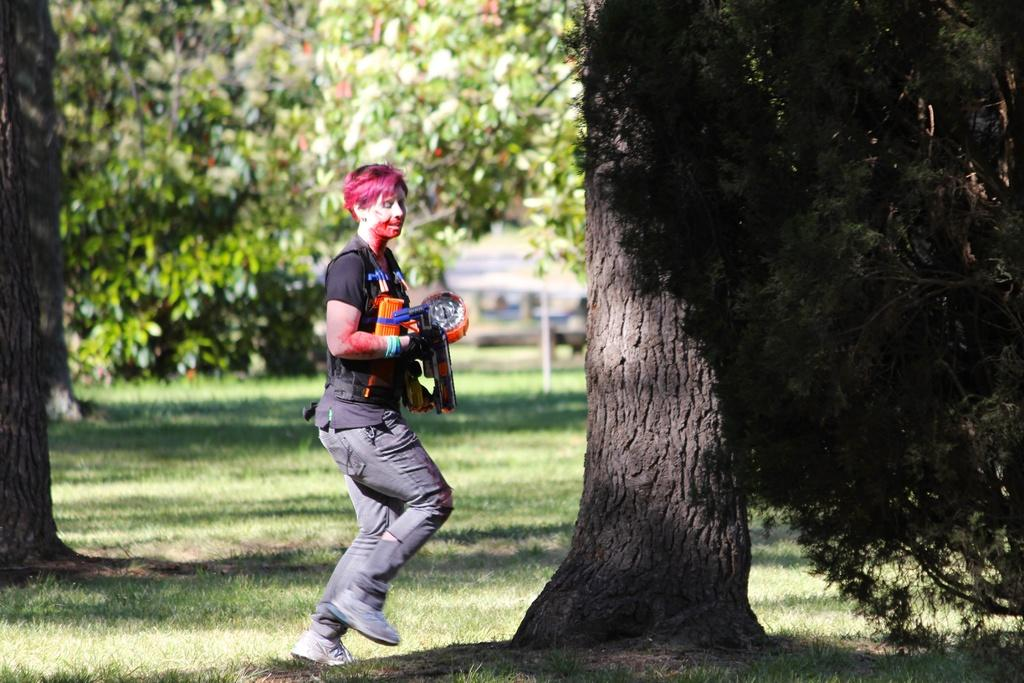What is the person in the image doing? The person is jumping in the image. What is the person wearing on their upper body? The person is wearing a black t-shirt. What is the person wearing on their lower body? The person is wearing black trousers. What is the person wearing on their feet? The person is wearing black shoes. What type of natural environment can be seen in the image? There are trees in the image. Can you see a pin holding the person's clothes together in the image? There is no pin visible in the image. Is the person in the image in a quiet environment? The image does not provide information about the noise level in the environment. 